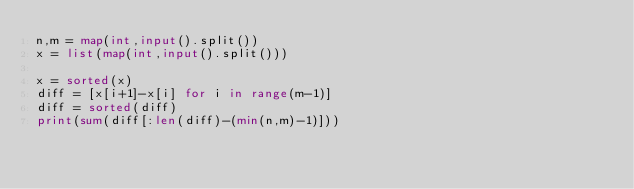<code> <loc_0><loc_0><loc_500><loc_500><_Python_>n,m = map(int,input().split())
x = list(map(int,input().split()))

x = sorted(x)
diff = [x[i+1]-x[i] for i in range(m-1)]
diff = sorted(diff)
print(sum(diff[:len(diff)-(min(n,m)-1)]))</code> 